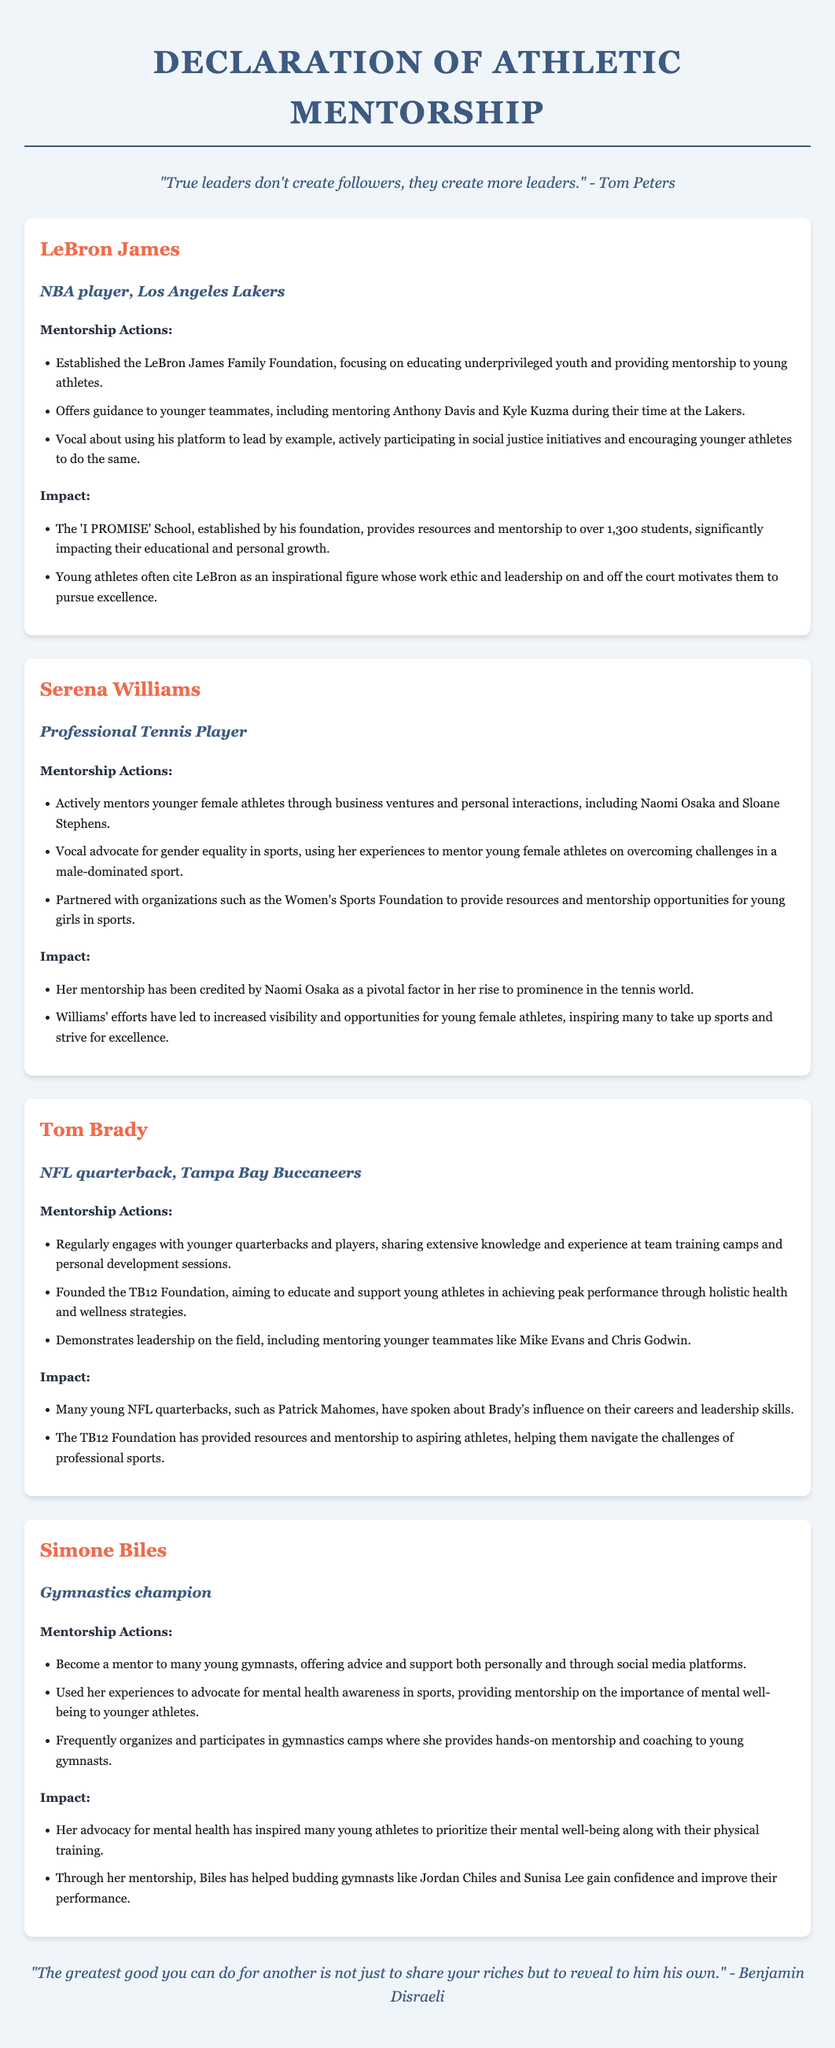What is the name of the foundation established by LeBron James? LeBron James established the LeBron James Family Foundation, which focuses on educating underprivileged youth.
Answer: LeBron James Family Foundation Who is a notable athlete mentored by Serena Williams? Naomi Osaka is mentioned as a young athlete who has been mentored by Serena Williams.
Answer: Naomi Osaka What sport does Tom Brady play? Tom Brady is identified as an NFL quarterback, which indicates he plays American football.
Answer: NFL How many students are impacted by the 'I PROMISE' School? The document states that the school provides resources and mentorship to over 1,300 students.
Answer: 1,300 What topic does Simone Biles advocate for in addition to gymnastics? Simone Biles advocates for mental health awareness in sports, which she uses to mentor younger athletes.
Answer: Mental health awareness Who founded the TB12 Foundation? The TB12 Foundation was founded by Tom Brady to support young athletes in achieving peak performance.
Answer: Tom Brady What did young NFL quarterbacks say about Tom Brady? Young NFL quarterbacks have spoken about Brady's influence on their careers and leadership skills.
Answer: Influence on their careers Which organization is partnered with Serena Williams for mentorship opportunities? Serena Williams is partnered with the Women's Sports Foundation to provide resources and mentorship.
Answer: Women's Sports Foundation What is a key trait of LeBron James as a leader? LeBron James is vocal about using his platform to lead by example, especially in social justice.
Answer: Lead by example 